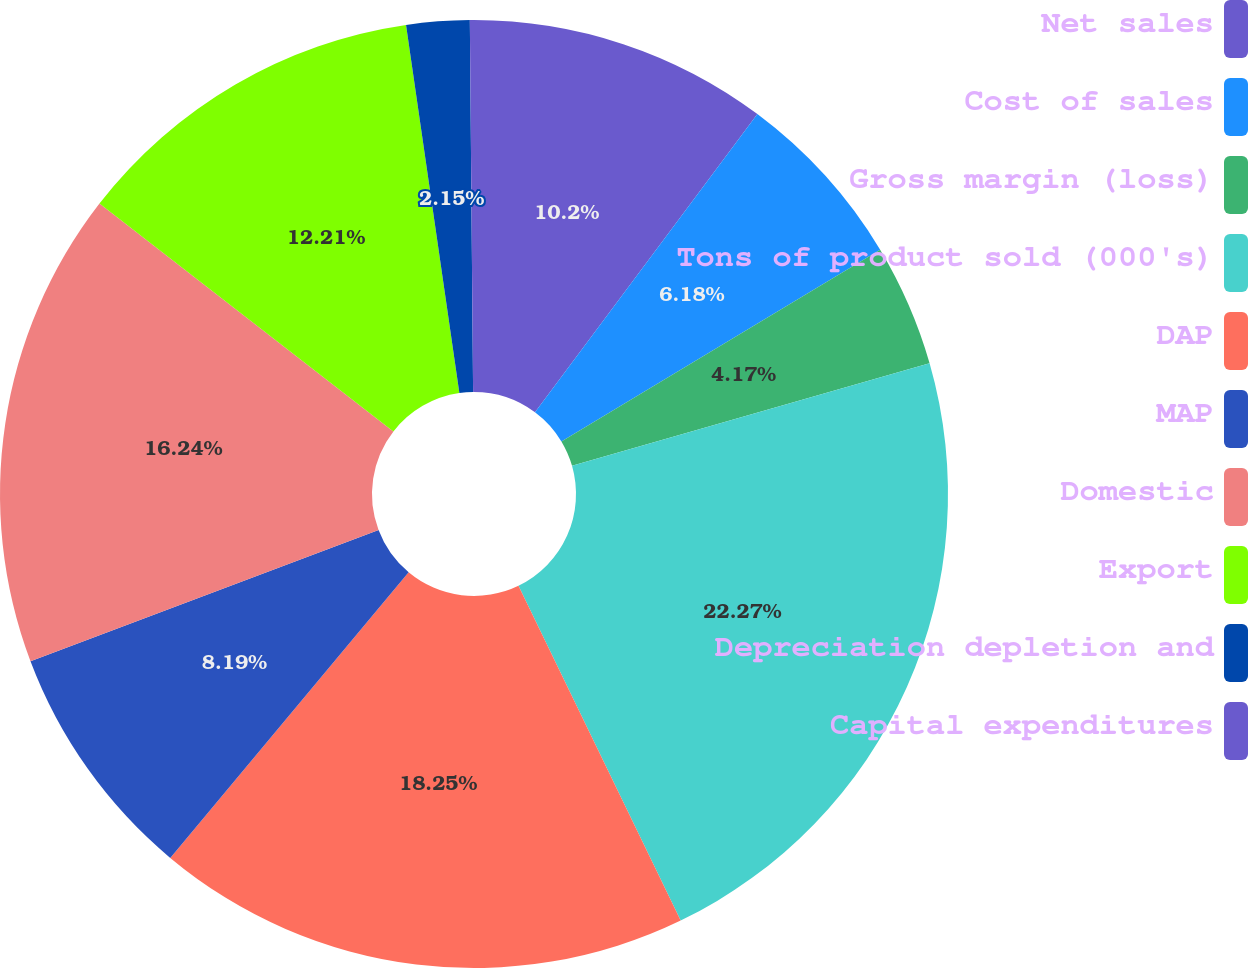Convert chart to OTSL. <chart><loc_0><loc_0><loc_500><loc_500><pie_chart><fcel>Net sales<fcel>Cost of sales<fcel>Gross margin (loss)<fcel>Tons of product sold (000's)<fcel>DAP<fcel>MAP<fcel>Domestic<fcel>Export<fcel>Depreciation depletion and<fcel>Capital expenditures<nl><fcel>10.2%<fcel>6.18%<fcel>4.17%<fcel>22.27%<fcel>18.25%<fcel>8.19%<fcel>16.24%<fcel>12.21%<fcel>2.15%<fcel>0.14%<nl></chart> 